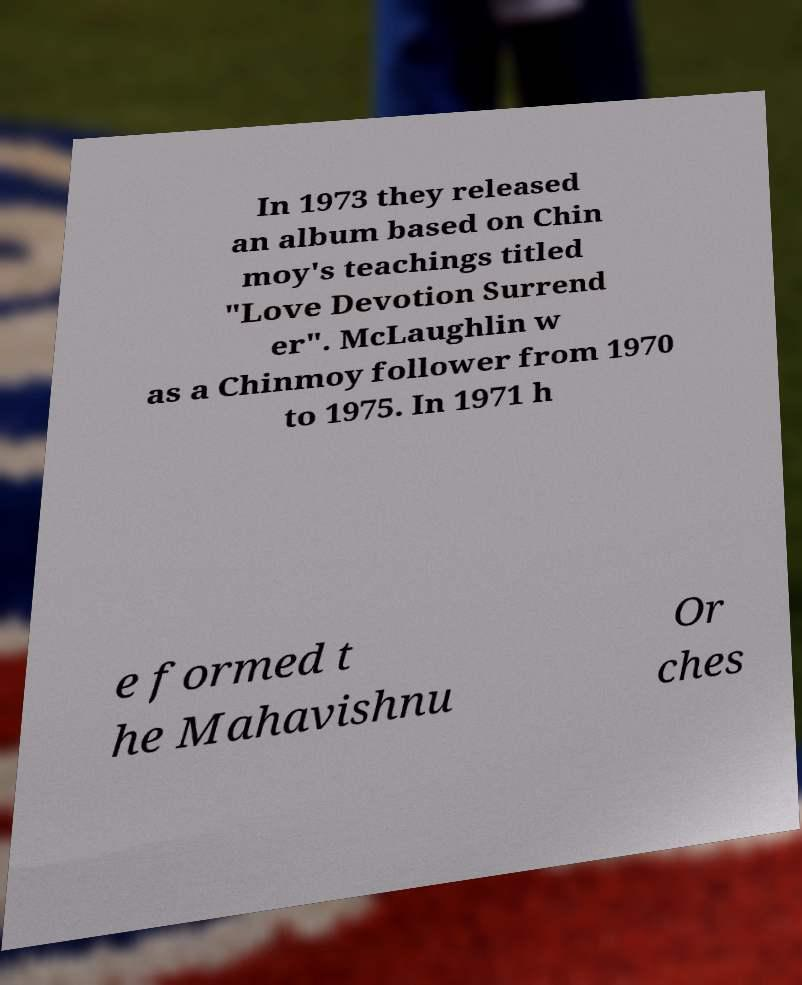Could you assist in decoding the text presented in this image and type it out clearly? In 1973 they released an album based on Chin moy's teachings titled "Love Devotion Surrend er". McLaughlin w as a Chinmoy follower from 1970 to 1975. In 1971 h e formed t he Mahavishnu Or ches 